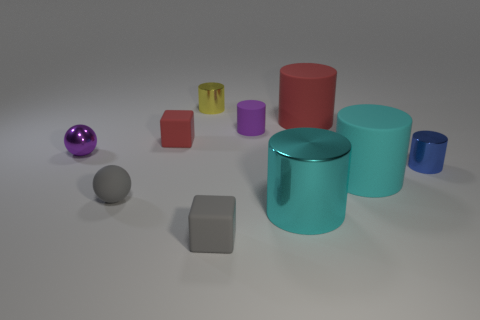Does the purple rubber object have the same shape as the small purple metal object?
Give a very brief answer. No. What is the color of the tiny matte block that is on the right side of the tiny object that is behind the large red matte cylinder?
Your answer should be compact. Gray. What is the size of the matte object that is on the right side of the gray matte ball and in front of the big cyan matte cylinder?
Ensure brevity in your answer.  Small. Are there any other things that have the same color as the large shiny cylinder?
Make the answer very short. Yes. There is a cyan object that is made of the same material as the yellow cylinder; what is its shape?
Provide a short and direct response. Cylinder. Does the purple shiny object have the same shape as the thing in front of the big cyan metallic cylinder?
Make the answer very short. No. What material is the purple thing that is left of the gray thing in front of the matte sphere?
Ensure brevity in your answer.  Metal. Are there an equal number of small gray spheres in front of the cyan metallic thing and tiny purple things?
Provide a short and direct response. No. Are there any other things that have the same material as the tiny red block?
Keep it short and to the point. Yes. There is a tiny object that is behind the small purple matte cylinder; does it have the same color as the metallic thing that is to the left of the small gray sphere?
Your answer should be compact. No. 